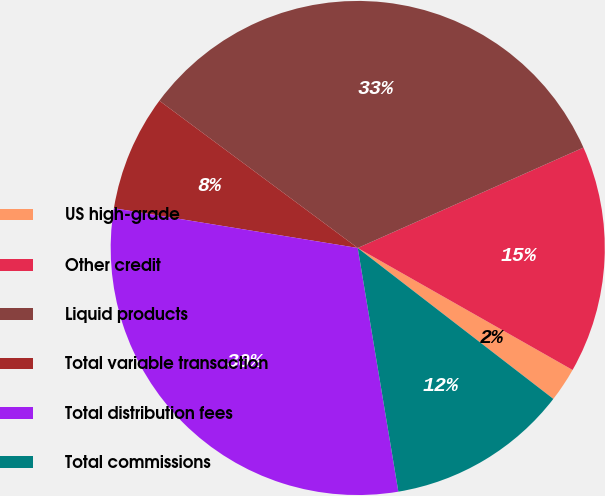<chart> <loc_0><loc_0><loc_500><loc_500><pie_chart><fcel>US high-grade<fcel>Other credit<fcel>Liquid products<fcel>Total variable transaction<fcel>Total distribution fees<fcel>Total commissions<nl><fcel>2.24%<fcel>14.88%<fcel>33.17%<fcel>7.59%<fcel>30.2%<fcel>11.91%<nl></chart> 